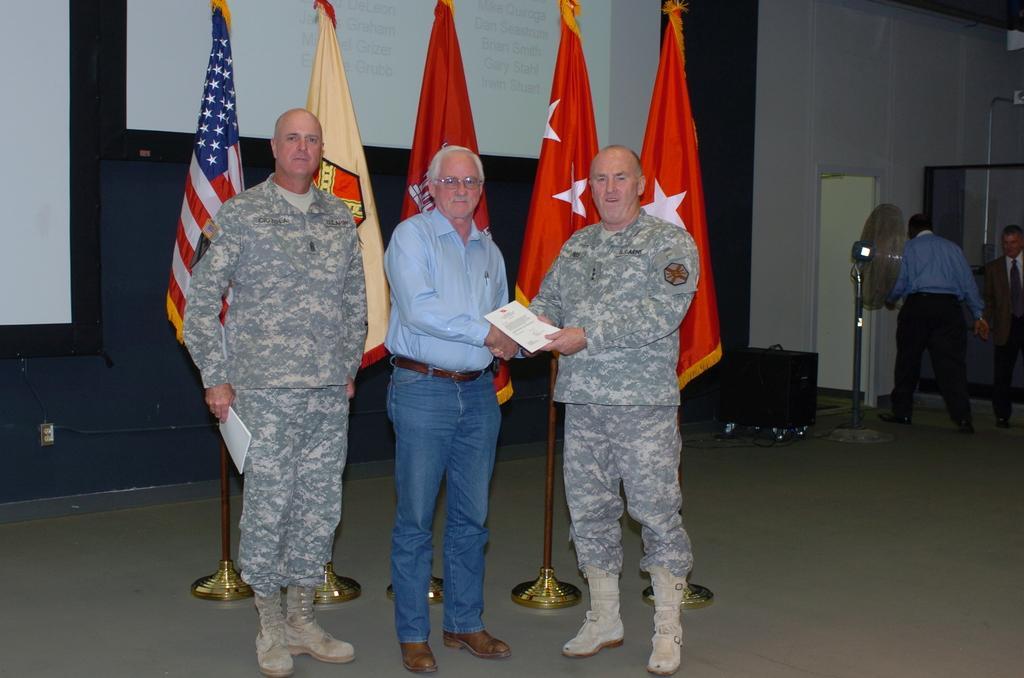Can you describe this image briefly? In the foreground of this image, there are three men standing and posing to a camera where two men shaking hands. In the background, there are five flags, two screen, a wall, table fan, a black object and two men walking on the floor. 